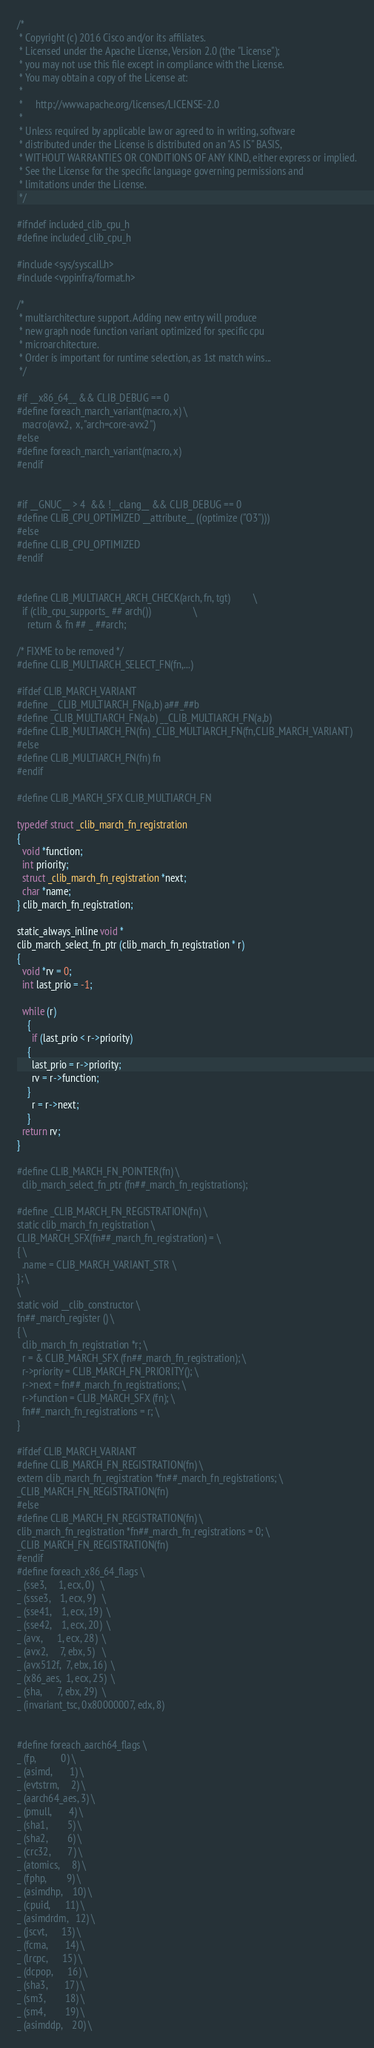<code> <loc_0><loc_0><loc_500><loc_500><_C_>/*
 * Copyright (c) 2016 Cisco and/or its affiliates.
 * Licensed under the Apache License, Version 2.0 (the "License");
 * you may not use this file except in compliance with the License.
 * You may obtain a copy of the License at:
 *
 *     http://www.apache.org/licenses/LICENSE-2.0
 *
 * Unless required by applicable law or agreed to in writing, software
 * distributed under the License is distributed on an "AS IS" BASIS,
 * WITHOUT WARRANTIES OR CONDITIONS OF ANY KIND, either express or implied.
 * See the License for the specific language governing permissions and
 * limitations under the License.
 */

#ifndef included_clib_cpu_h
#define included_clib_cpu_h

#include <sys/syscall.h>
#include <vppinfra/format.h>

/*
 * multiarchitecture support. Adding new entry will produce
 * new graph node function variant optimized for specific cpu
 * microarchitecture.
 * Order is important for runtime selection, as 1st match wins...
 */

#if __x86_64__ && CLIB_DEBUG == 0
#define foreach_march_variant(macro, x) \
  macro(avx2,  x, "arch=core-avx2")
#else
#define foreach_march_variant(macro, x)
#endif


#if __GNUC__ > 4  && !__clang__ && CLIB_DEBUG == 0
#define CLIB_CPU_OPTIMIZED __attribute__ ((optimize ("O3")))
#else
#define CLIB_CPU_OPTIMIZED
#endif


#define CLIB_MULTIARCH_ARCH_CHECK(arch, fn, tgt)			\
  if (clib_cpu_supports_ ## arch())					\
    return & fn ## _ ##arch;

/* FIXME to be removed */
#define CLIB_MULTIARCH_SELECT_FN(fn,...)

#ifdef CLIB_MARCH_VARIANT
#define __CLIB_MULTIARCH_FN(a,b) a##_##b
#define _CLIB_MULTIARCH_FN(a,b) __CLIB_MULTIARCH_FN(a,b)
#define CLIB_MULTIARCH_FN(fn) _CLIB_MULTIARCH_FN(fn,CLIB_MARCH_VARIANT)
#else
#define CLIB_MULTIARCH_FN(fn) fn
#endif

#define CLIB_MARCH_SFX CLIB_MULTIARCH_FN

typedef struct _clib_march_fn_registration
{
  void *function;
  int priority;
  struct _clib_march_fn_registration *next;
  char *name;
} clib_march_fn_registration;

static_always_inline void *
clib_march_select_fn_ptr (clib_march_fn_registration * r)
{
  void *rv = 0;
  int last_prio = -1;

  while (r)
    {
      if (last_prio < r->priority)
	{
	  last_prio = r->priority;
	  rv = r->function;
	}
      r = r->next;
    }
  return rv;
}

#define CLIB_MARCH_FN_POINTER(fn) \
  clib_march_select_fn_ptr (fn##_march_fn_registrations);

#define _CLIB_MARCH_FN_REGISTRATION(fn) \
static clib_march_fn_registration \
CLIB_MARCH_SFX(fn##_march_fn_registration) = \
{ \
  .name = CLIB_MARCH_VARIANT_STR \
}; \
\
static void __clib_constructor \
fn##_march_register () \
{ \
  clib_march_fn_registration *r; \
  r = & CLIB_MARCH_SFX (fn##_march_fn_registration); \
  r->priority = CLIB_MARCH_FN_PRIORITY(); \
  r->next = fn##_march_fn_registrations; \
  r->function = CLIB_MARCH_SFX (fn); \
  fn##_march_fn_registrations = r; \
}

#ifdef CLIB_MARCH_VARIANT
#define CLIB_MARCH_FN_REGISTRATION(fn) \
extern clib_march_fn_registration *fn##_march_fn_registrations; \
_CLIB_MARCH_FN_REGISTRATION(fn)
#else
#define CLIB_MARCH_FN_REGISTRATION(fn) \
clib_march_fn_registration *fn##_march_fn_registrations = 0; \
_CLIB_MARCH_FN_REGISTRATION(fn)
#endif
#define foreach_x86_64_flags \
_ (sse3,     1, ecx, 0)   \
_ (ssse3,    1, ecx, 9)   \
_ (sse41,    1, ecx, 19)  \
_ (sse42,    1, ecx, 20)  \
_ (avx,      1, ecx, 28)  \
_ (avx2,     7, ebx, 5)   \
_ (avx512f,  7, ebx, 16)  \
_ (x86_aes,  1, ecx, 25)  \
_ (sha,      7, ebx, 29)  \
_ (invariant_tsc, 0x80000007, edx, 8)


#define foreach_aarch64_flags \
_ (fp,          0) \
_ (asimd,       1) \
_ (evtstrm,     2) \
_ (aarch64_aes, 3) \
_ (pmull,       4) \
_ (sha1,        5) \
_ (sha2,        6) \
_ (crc32,       7) \
_ (atomics,     8) \
_ (fphp,        9) \
_ (asimdhp,    10) \
_ (cpuid,      11) \
_ (asimdrdm,   12) \
_ (jscvt,      13) \
_ (fcma,       14) \
_ (lrcpc,      15) \
_ (dcpop,      16) \
_ (sha3,       17) \
_ (sm3,        18) \
_ (sm4,        19) \
_ (asimddp,    20) \</code> 